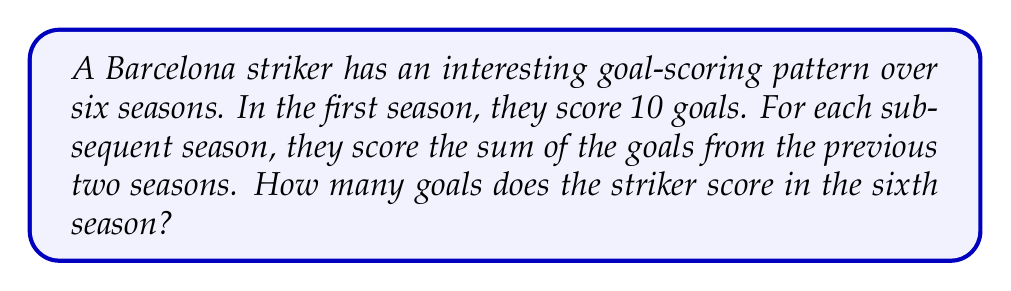Can you answer this question? Let's break this down step-by-step:

1) First, let's list out the goals for each season:
   Season 1: 10 goals (given)
   Season 2: We need to determine this

2) For Season 2, we don't have a previous season to add to Season 1, so let's assume it's also 10 goals.
   Season 2: 10 goals

3) Now we can calculate the rest:
   Season 3: 10 + 10 = 20 goals
   Season 4: 10 + 20 = 30 goals
   Season 5: 20 + 30 = 50 goals
   Season 6: 30 + 50 = 80 goals

4) We can represent this sequence mathematically:
   Let $a_n$ be the number of goals in season $n$.
   Then, $a_n = a_{n-1} + a_{n-2}$ for $n \geq 3$

5) This is actually a famous sequence known as the Fibonacci sequence, with a different starting point.

6) We can verify:
   $a_1 = 10$
   $a_2 = 10$
   $a_3 = a_2 + a_1 = 10 + 10 = 20$
   $a_4 = a_3 + a_2 = 20 + 10 = 30$
   $a_5 = a_4 + a_3 = 30 + 20 = 50$
   $a_6 = a_5 + a_4 = 50 + 30 = 80$

Therefore, in the sixth season, the striker scores 80 goals.
Answer: 80 goals 